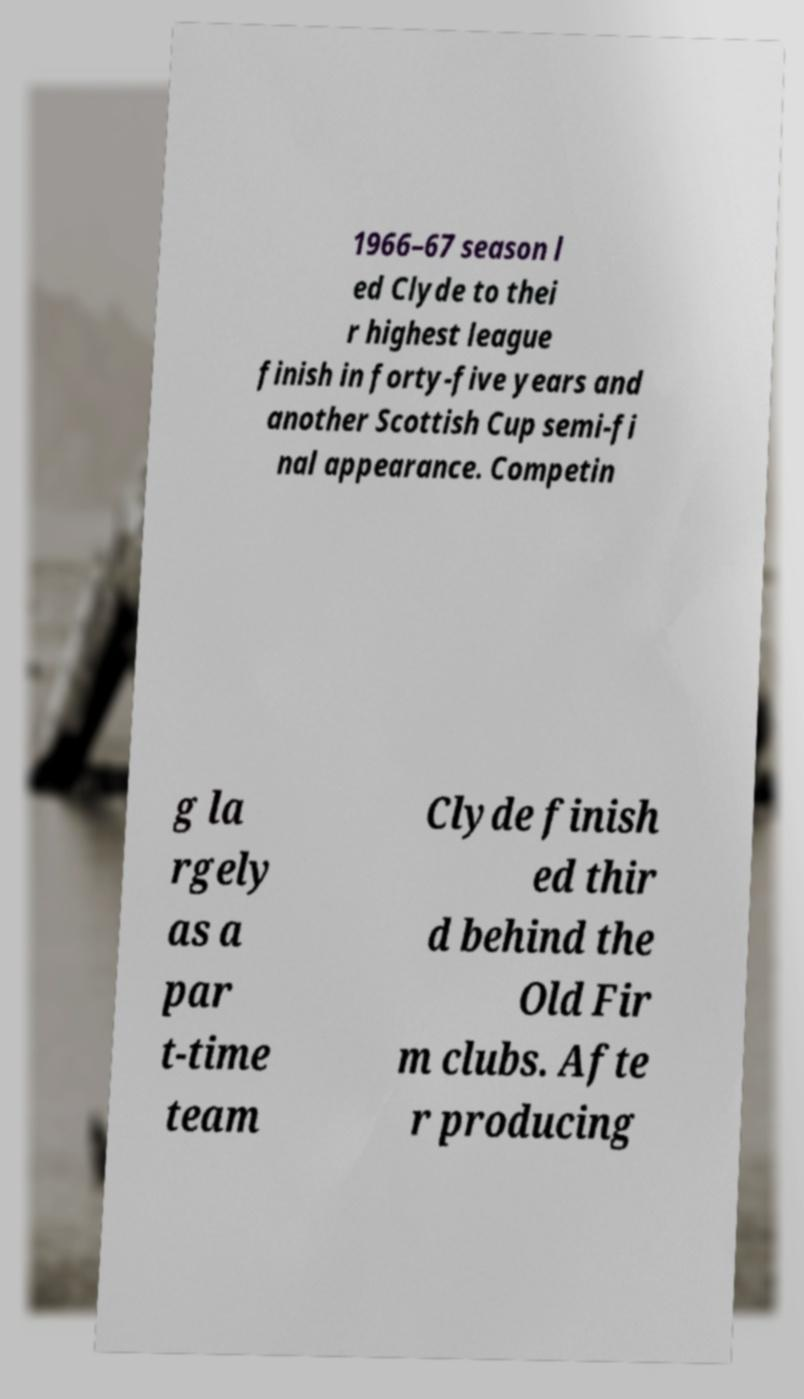Could you extract and type out the text from this image? 1966–67 season l ed Clyde to thei r highest league finish in forty-five years and another Scottish Cup semi-fi nal appearance. Competin g la rgely as a par t-time team Clyde finish ed thir d behind the Old Fir m clubs. Afte r producing 